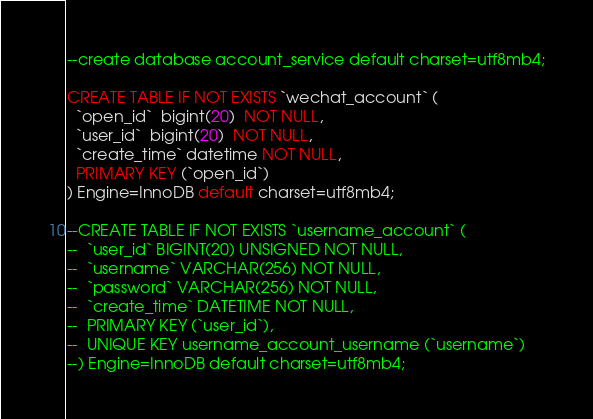Convert code to text. <code><loc_0><loc_0><loc_500><loc_500><_SQL_>
--create database account_service default charset=utf8mb4;

CREATE TABLE IF NOT EXISTS `wechat_account` (
  `open_id`  bigint(20)  NOT NULL,
  `user_id`  bigint(20)  NOT NULL,
  `create_time` datetime NOT NULL,
  PRIMARY KEY (`open_id`)
) Engine=InnoDB default charset=utf8mb4;

--CREATE TABLE IF NOT EXISTS `username_account` (
--  `user_id` BIGINT(20) UNSIGNED NOT NULL,
--  `username` VARCHAR(256) NOT NULL,
--  `password` VARCHAR(256) NOT NULL,
--  `create_time` DATETIME NOT NULL,
--  PRIMARY KEY (`user_id`),
--  UNIQUE KEY username_account_username (`username`)
--) Engine=InnoDB default charset=utf8mb4;

</code> 